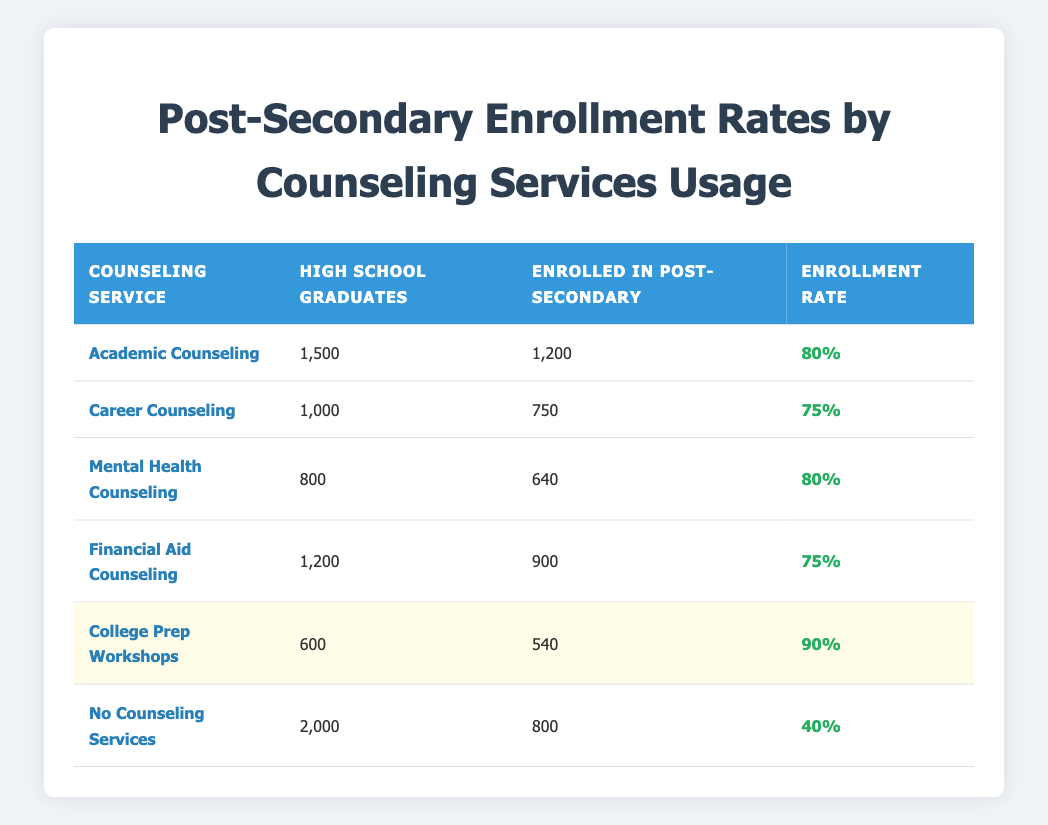What is the enrollment rate for Academic Counseling? The table shows that the enrollment rate for Academic Counseling is listed directly in the last column for that row, which states 80.
Answer: 80 How many high school graduates utilized Mental Health Counseling? The table indicates that 800 high school graduates used Mental Health Counseling, as reflected in the second column for that row.
Answer: 800 Which counseling service has the highest enrollment rate? By comparing the enrollment rates provided in the last column, College Prep Workshops has the highest rate at 90, which is greater than all other services' rates.
Answer: College Prep Workshops What is the total number of high school graduates that enrolled in post-secondary education after using Financial Aid Counseling? The table shows that 900 students enrolled in post-secondary education after using Financial Aid Counseling, as given in the third column of that row.
Answer: 900 Is it true that no counseling services resulted in a higher enrollment rate than 50? Looking at the enrollment rate for 'No Counseling Services', which is 40 in the last column, it confirms that this rate is indeed below 50. Therefore, the statement is false.
Answer: False What is the difference in enrollment rates between College Prep Workshops and Career Counseling? College Prep Workshops has an enrollment rate of 90, whereas Career Counseling has an enrollment rate of 75. The difference is 90 - 75 = 15.
Answer: 15 If we consider only those who had academic counseling and college prep workshops, what is the total number of students enrolled in post-secondary education? For Academic Counseling, 1200 students enrolled, and for College Prep Workshops, 540 students enrolled. Adding these gives 1200 + 540 = 1740 enrolled students.
Answer: 1740 What percentage of high school graduates who did not utilize counseling services enrolled in post-secondary education? In the row for 'No Counseling Services', there were 2000 high school graduates, and only 800 enrolled. To find the percentage, we calculate (800 / 2000) * 100, which gives 40%.
Answer: 40 Which two counseling services had the same enrollment rate? By reviewing the enrollment rates in the last column, Academic Counseling and Mental Health Counseling both have an enrollment rate of 80, thus they share the same rate.
Answer: Academic Counseling and Mental Health Counseling 